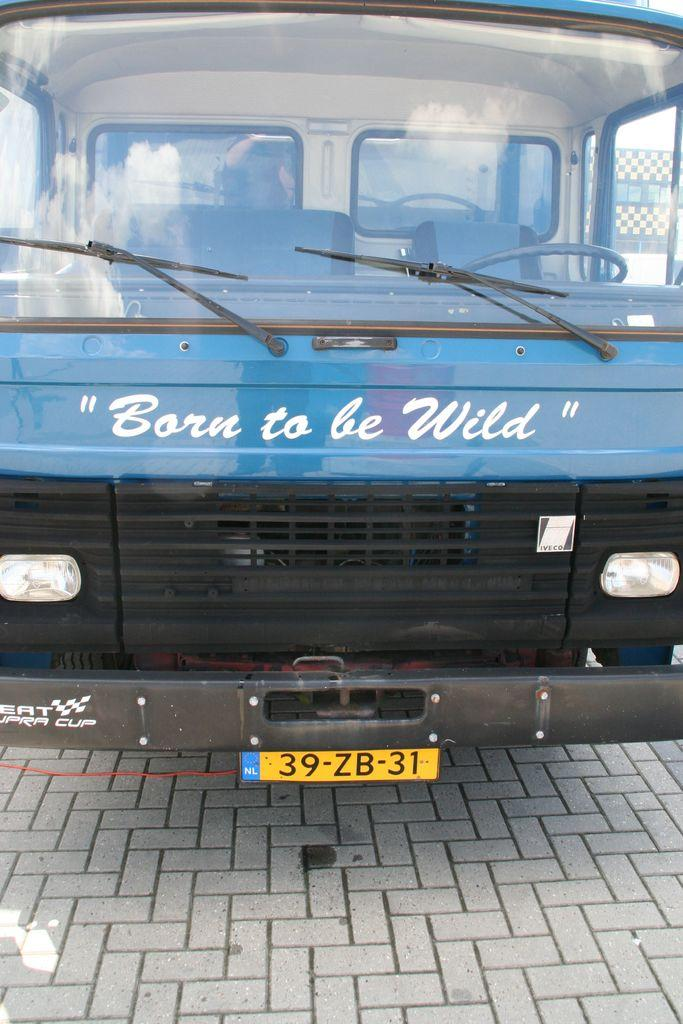Provide a one-sentence caption for the provided image. the blue vehicle says Born to be Wild on the front. 